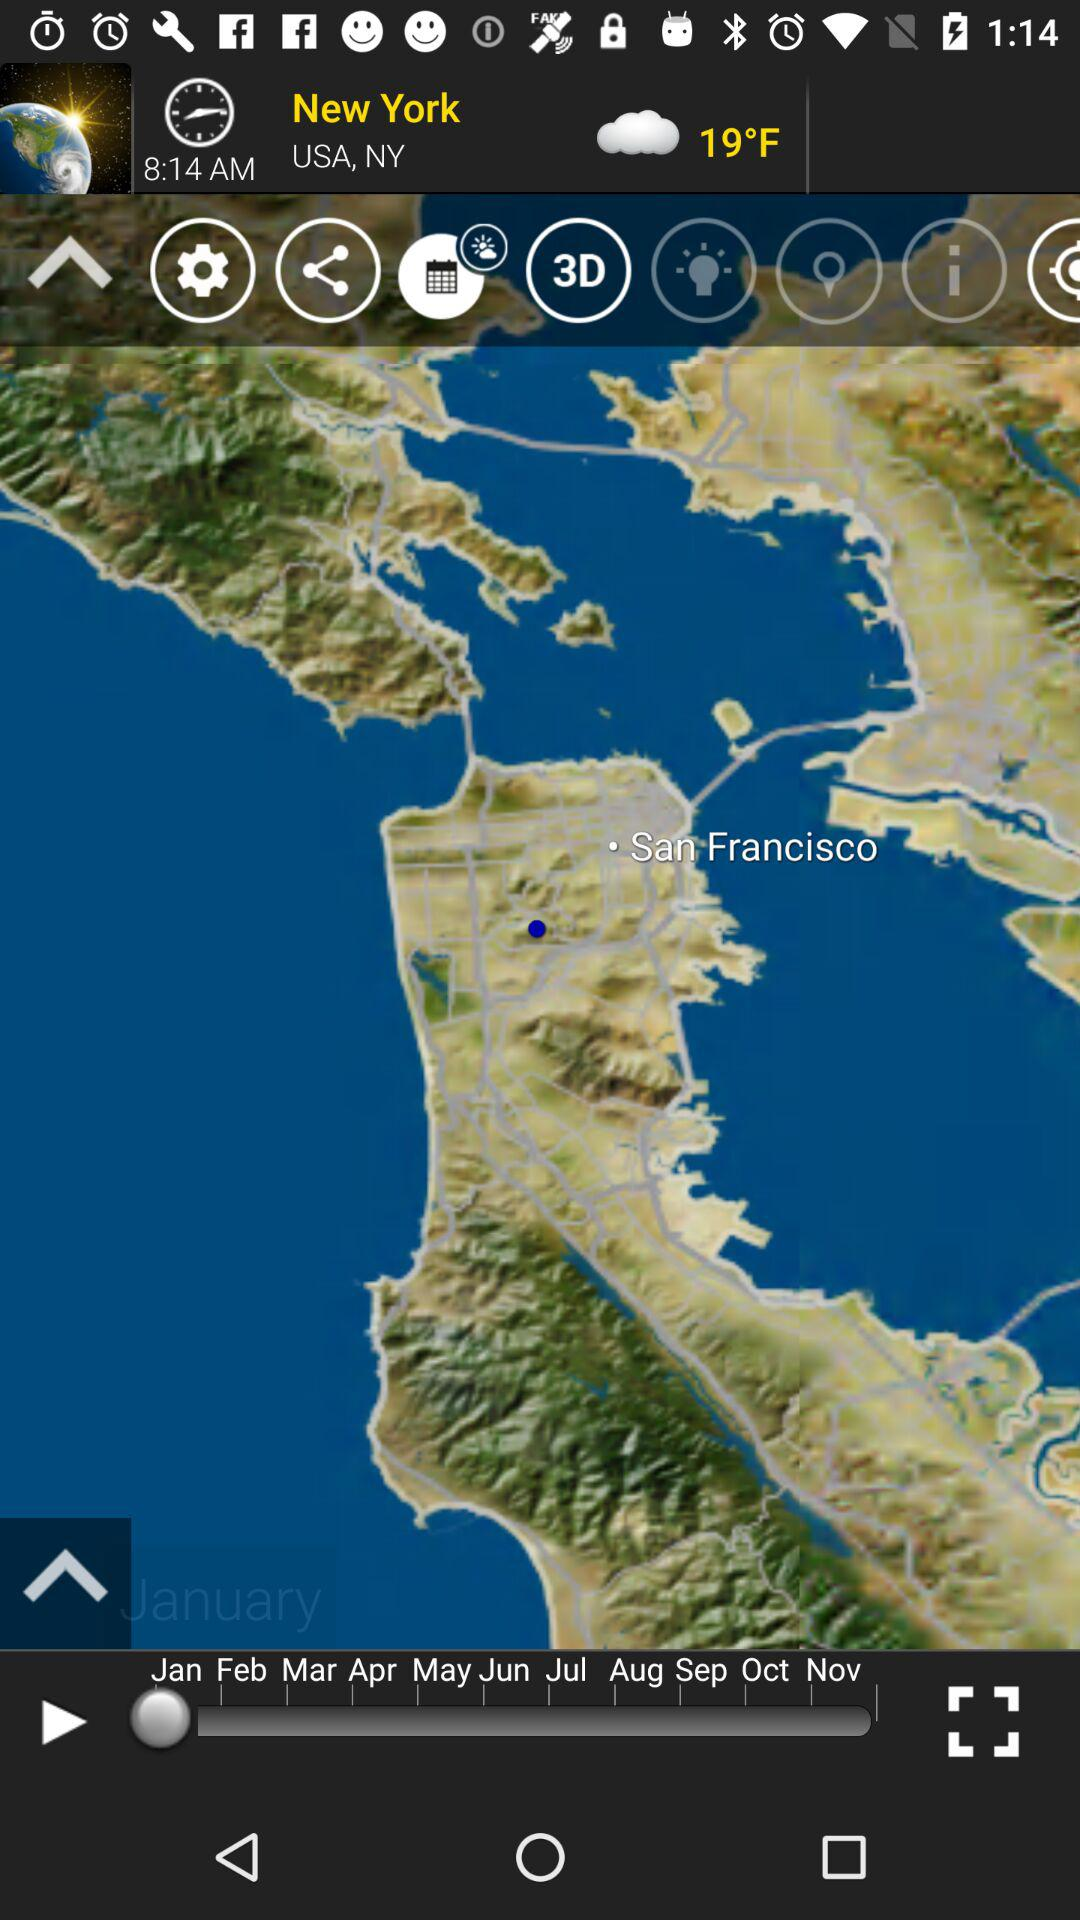What is the current location? The current location is New York, USA, NY. 